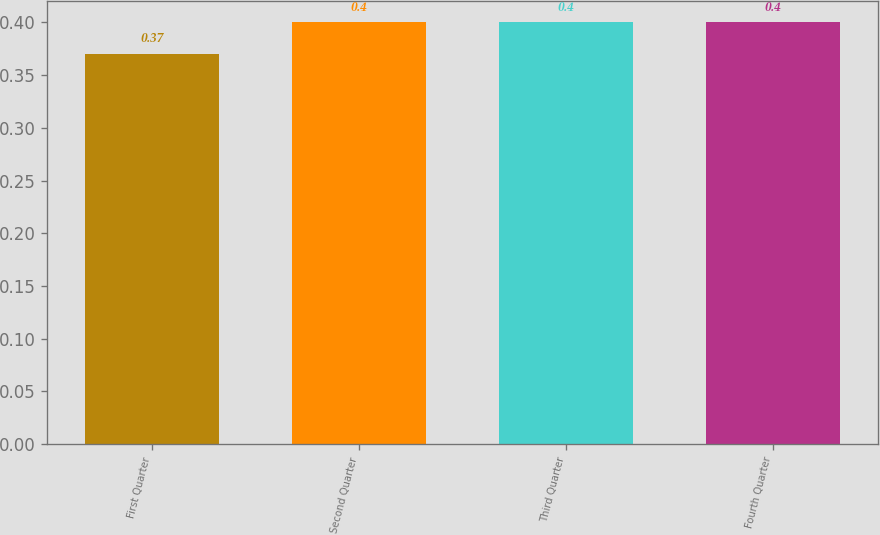Convert chart to OTSL. <chart><loc_0><loc_0><loc_500><loc_500><bar_chart><fcel>First Quarter<fcel>Second Quarter<fcel>Third Quarter<fcel>Fourth Quarter<nl><fcel>0.37<fcel>0.4<fcel>0.4<fcel>0.4<nl></chart> 